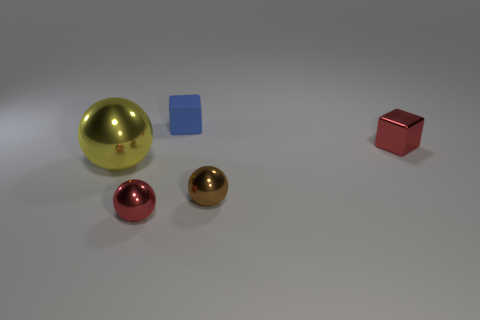Add 1 tiny brown objects. How many objects exist? 6 Subtract all cubes. How many objects are left? 3 Subtract all blue shiny objects. Subtract all small shiny objects. How many objects are left? 2 Add 3 large yellow things. How many large yellow things are left? 4 Add 4 big blue shiny blocks. How many big blue shiny blocks exist? 4 Subtract 0 yellow blocks. How many objects are left? 5 